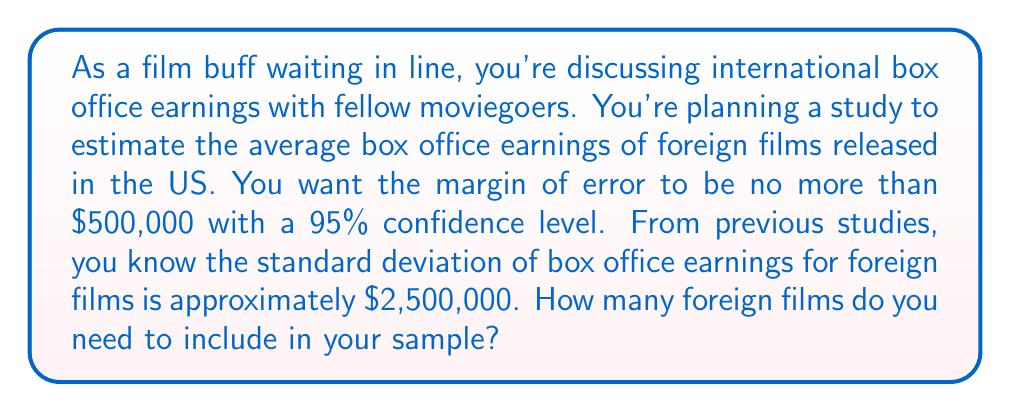What is the answer to this math problem? Let's approach this step-by-step:

1) The formula for sample size calculation is:

   $$n = \left(\frac{z_{\alpha/2} \cdot \sigma}{E}\right)^2$$

   Where:
   $n$ = sample size
   $z_{\alpha/2}$ = z-score for the desired confidence level
   $\sigma$ = population standard deviation
   $E$ = margin of error

2) We're given:
   - Confidence level = 95%, so $z_{\alpha/2} = 1.96$
   - $\sigma = \$2,500,000$
   - $E = \$500,000$

3) Let's substitute these values into our formula:

   $$n = \left(\frac{1.96 \cdot 2,500,000}{500,000}\right)^2$$

4) Simplify inside the parentheses:

   $$n = (1.96 \cdot 5)^2$$

5) Calculate:

   $$n = 9.8^2 = 96.04$$

6) Since we can't sample a fraction of a film, we round up to the nearest whole number.
Answer: 97 films 